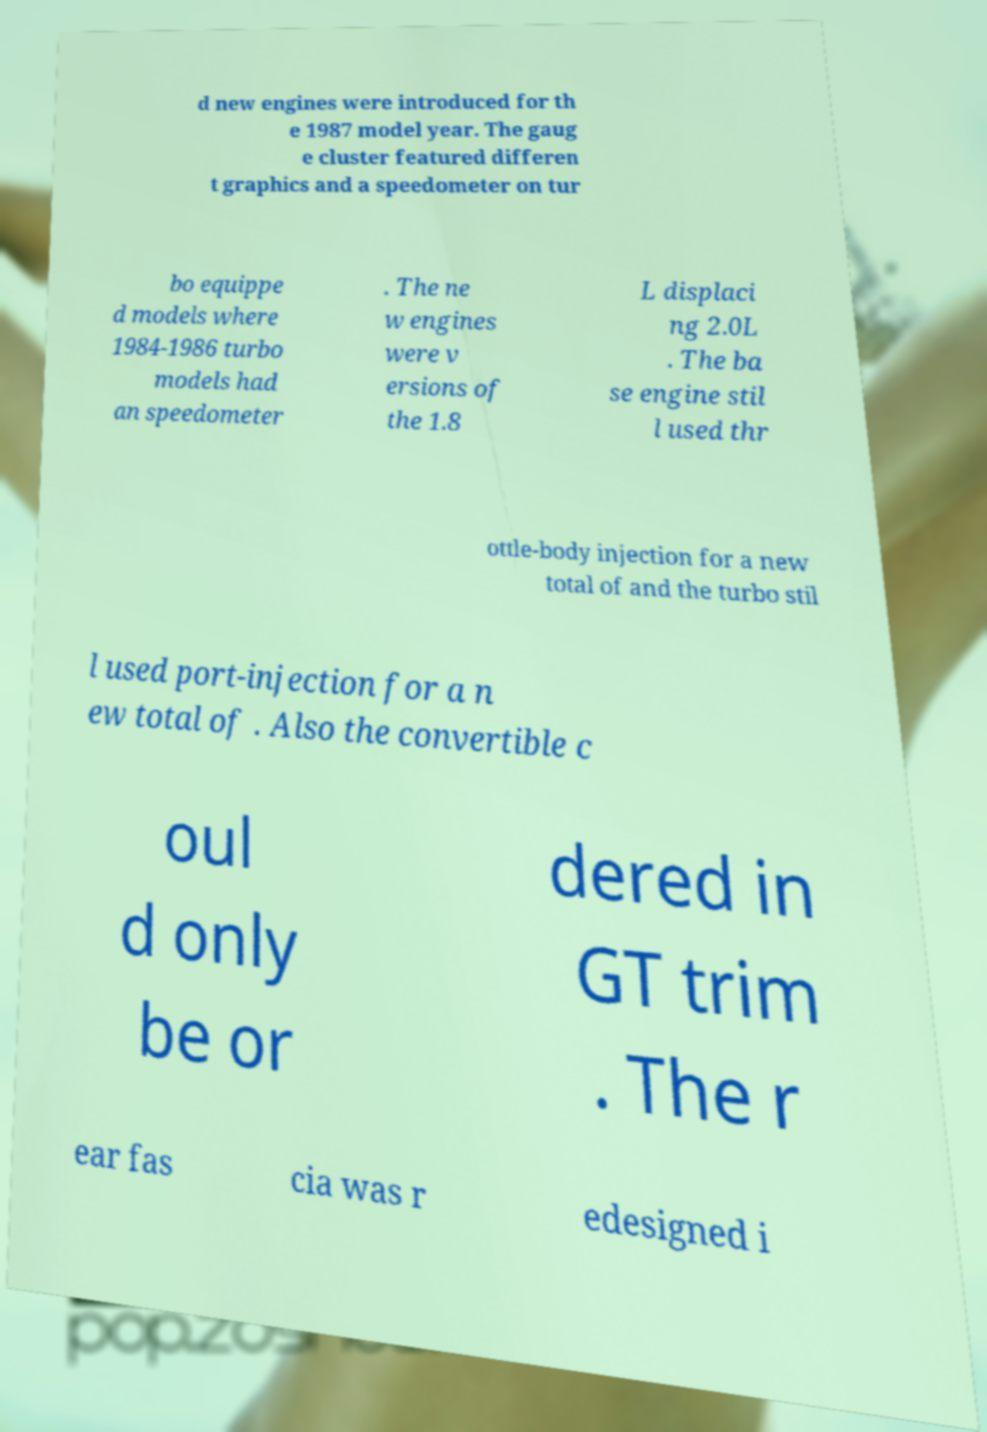Please read and relay the text visible in this image. What does it say? d new engines were introduced for th e 1987 model year. The gaug e cluster featured differen t graphics and a speedometer on tur bo equippe d models where 1984-1986 turbo models had an speedometer . The ne w engines were v ersions of the 1.8 L displaci ng 2.0L . The ba se engine stil l used thr ottle-body injection for a new total of and the turbo stil l used port-injection for a n ew total of . Also the convertible c oul d only be or dered in GT trim . The r ear fas cia was r edesigned i 